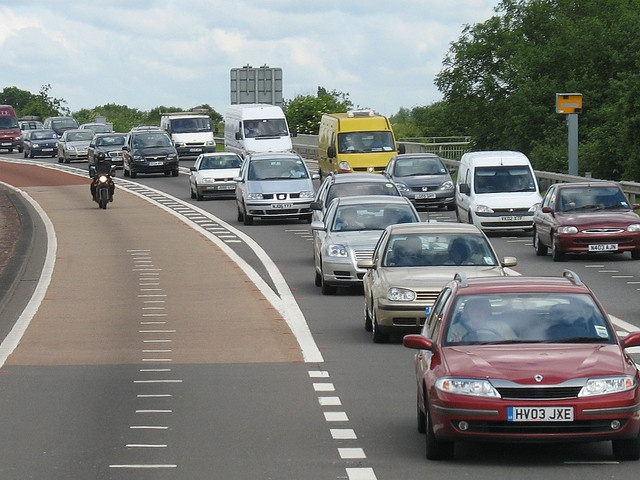Describe the objects in this image and their specific colors. I can see car in lightblue, black, darkgray, gray, and brown tones, car in lightblue, darkgray, gray, black, and lightgray tones, car in lightblue, gray, black, darkgray, and maroon tones, car in lightblue, darkgray, gray, lightgray, and black tones, and car in lightblue, gray, darkgray, black, and lightgray tones in this image. 